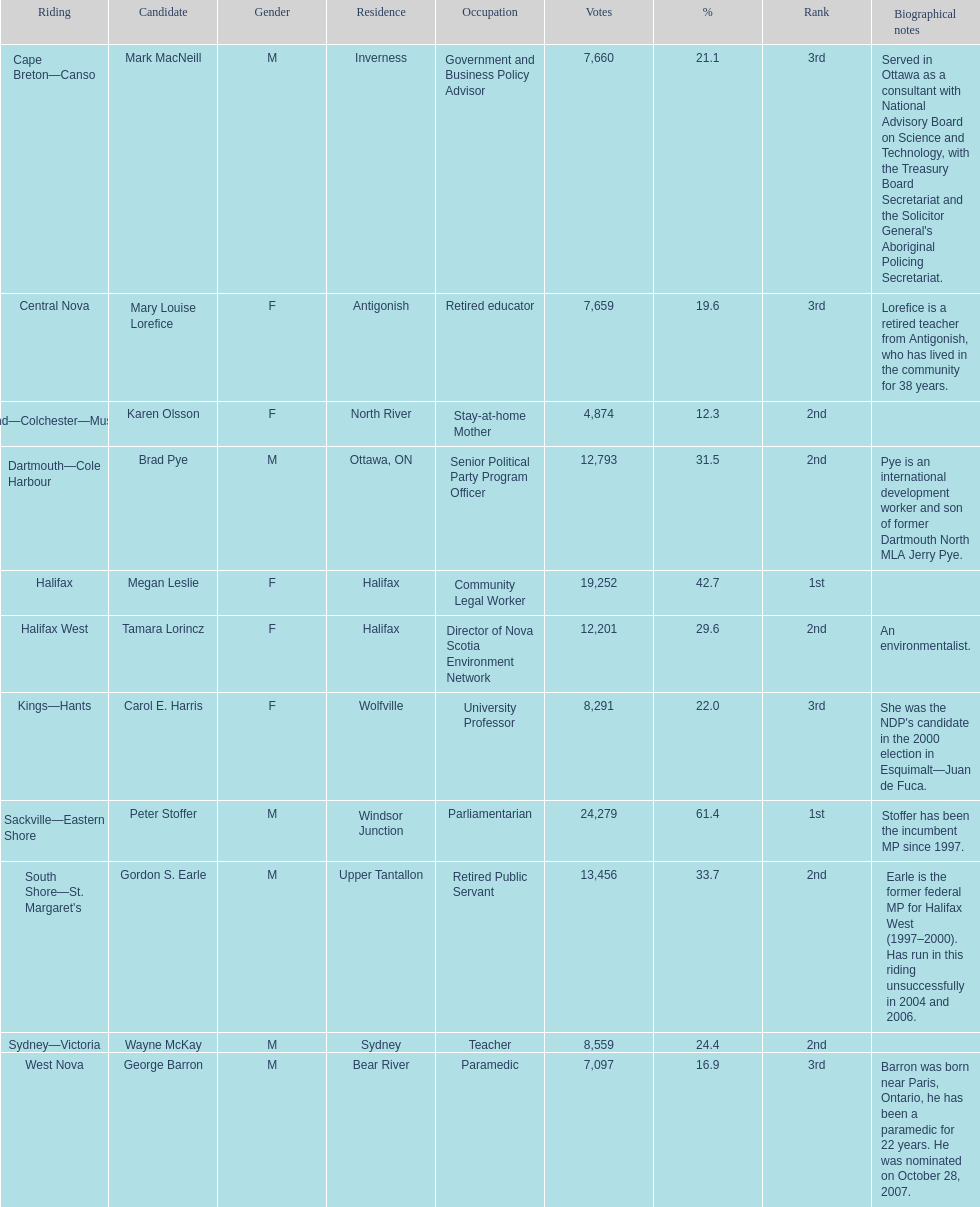Who received the least amount of votes? Karen Olsson. 